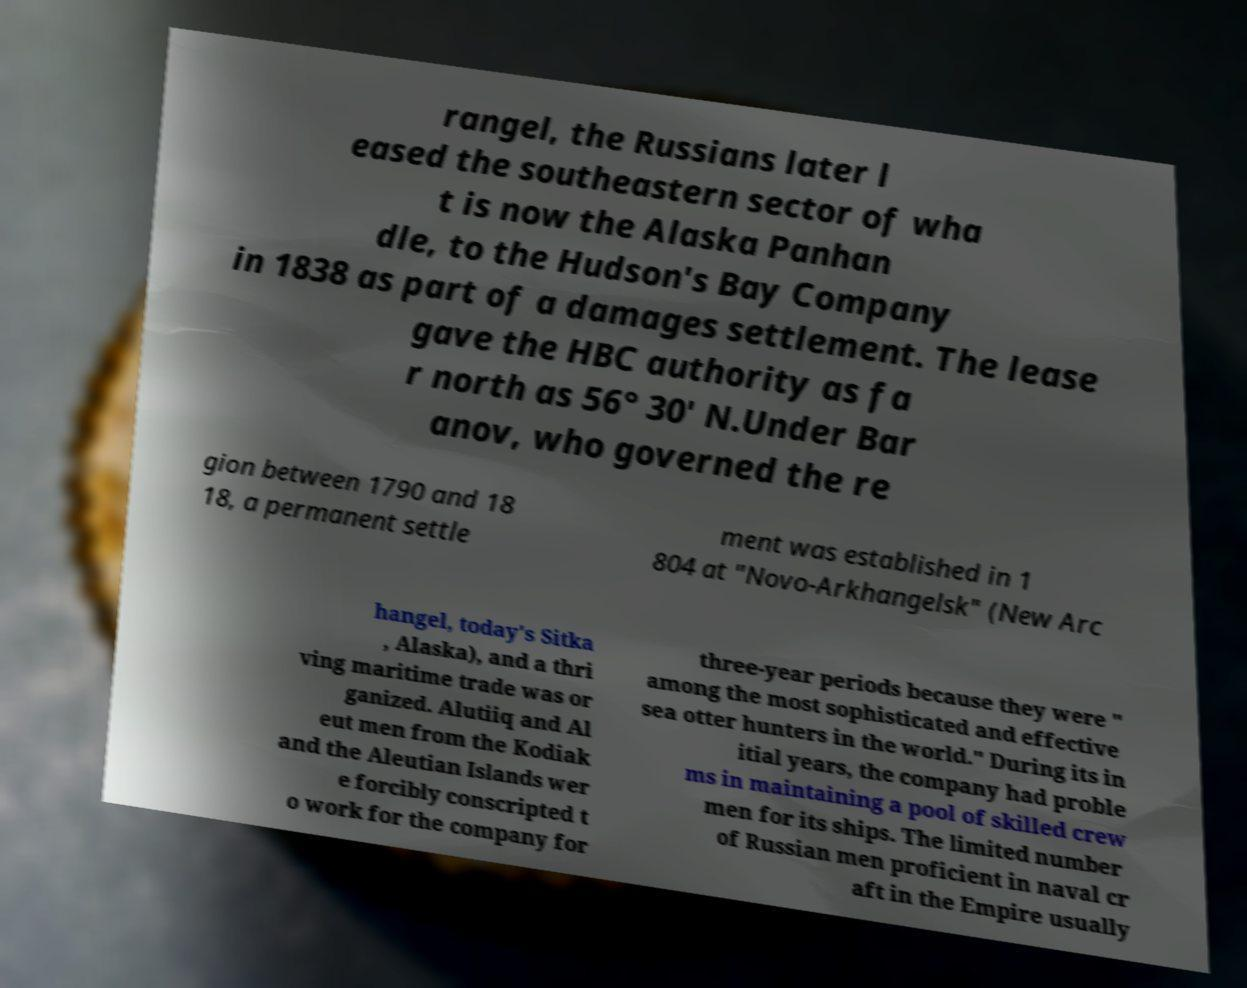Could you extract and type out the text from this image? rangel, the Russians later l eased the southeastern sector of wha t is now the Alaska Panhan dle, to the Hudson's Bay Company in 1838 as part of a damages settlement. The lease gave the HBC authority as fa r north as 56° 30' N.Under Bar anov, who governed the re gion between 1790 and 18 18, a permanent settle ment was established in 1 804 at "Novo-Arkhangelsk" (New Arc hangel, today's Sitka , Alaska), and a thri ving maritime trade was or ganized. Alutiiq and Al eut men from the Kodiak and the Aleutian Islands wer e forcibly conscripted t o work for the company for three-year periods because they were " among the most sophisticated and effective sea otter hunters in the world." During its in itial years, the company had proble ms in maintaining a pool of skilled crew men for its ships. The limited number of Russian men proficient in naval cr aft in the Empire usually 